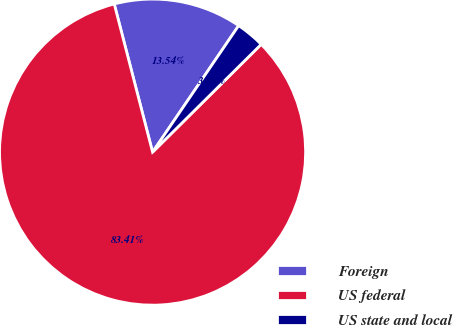Convert chart. <chart><loc_0><loc_0><loc_500><loc_500><pie_chart><fcel>Foreign<fcel>US federal<fcel>US state and local<nl><fcel>13.54%<fcel>83.4%<fcel>3.05%<nl></chart> 